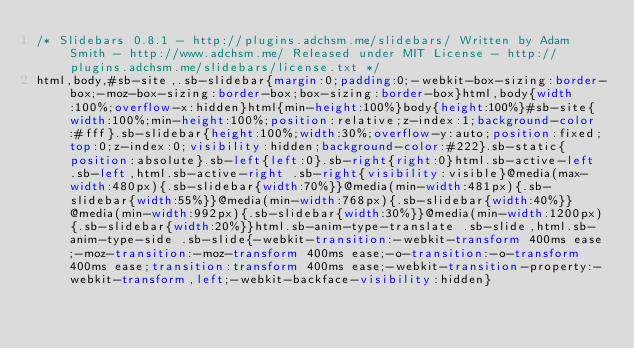Convert code to text. <code><loc_0><loc_0><loc_500><loc_500><_CSS_>/* Slidebars 0.8.1 - http://plugins.adchsm.me/slidebars/ Written by Adam Smith - http://www.adchsm.me/ Released under MIT License - http://plugins.adchsm.me/slidebars/license.txt */
html,body,#sb-site,.sb-slidebar{margin:0;padding:0;-webkit-box-sizing:border-box;-moz-box-sizing:border-box;box-sizing:border-box}html,body{width:100%;overflow-x:hidden}html{min-height:100%}body{height:100%}#sb-site{width:100%;min-height:100%;position:relative;z-index:1;background-color:#fff}.sb-slidebar{height:100%;width:30%;overflow-y:auto;position:fixed;top:0;z-index:0;visibility:hidden;background-color:#222}.sb-static{position:absolute}.sb-left{left:0}.sb-right{right:0}html.sb-active-left .sb-left,html.sb-active-right .sb-right{visibility:visible}@media(max-width:480px){.sb-slidebar{width:70%}}@media(min-width:481px){.sb-slidebar{width:55%}}@media(min-width:768px){.sb-slidebar{width:40%}}@media(min-width:992px){.sb-slidebar{width:30%}}@media(min-width:1200px){.sb-slidebar{width:20%}}html.sb-anim-type-translate .sb-slide,html.sb-anim-type-side .sb-slide{-webkit-transition:-webkit-transform 400ms ease;-moz-transition:-moz-transform 400ms ease;-o-transition:-o-transform 400ms ease;transition:transform 400ms ease;-webkit-transition-property:-webkit-transform,left;-webkit-backface-visibility:hidden}</code> 